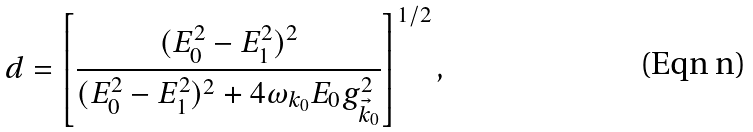Convert formula to latex. <formula><loc_0><loc_0><loc_500><loc_500>d = \left [ \frac { ( E _ { 0 } ^ { 2 } - E _ { 1 } ^ { 2 } ) ^ { 2 } } { ( E _ { 0 } ^ { 2 } - E _ { 1 } ^ { 2 } ) ^ { 2 } + 4 \omega _ { k _ { 0 } } E _ { 0 } g _ { \vec { k } _ { 0 } } ^ { 2 } } \right ] ^ { 1 / 2 } ,</formula> 